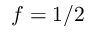Convert formula to latex. <formula><loc_0><loc_0><loc_500><loc_500>f = 1 / 2</formula> 